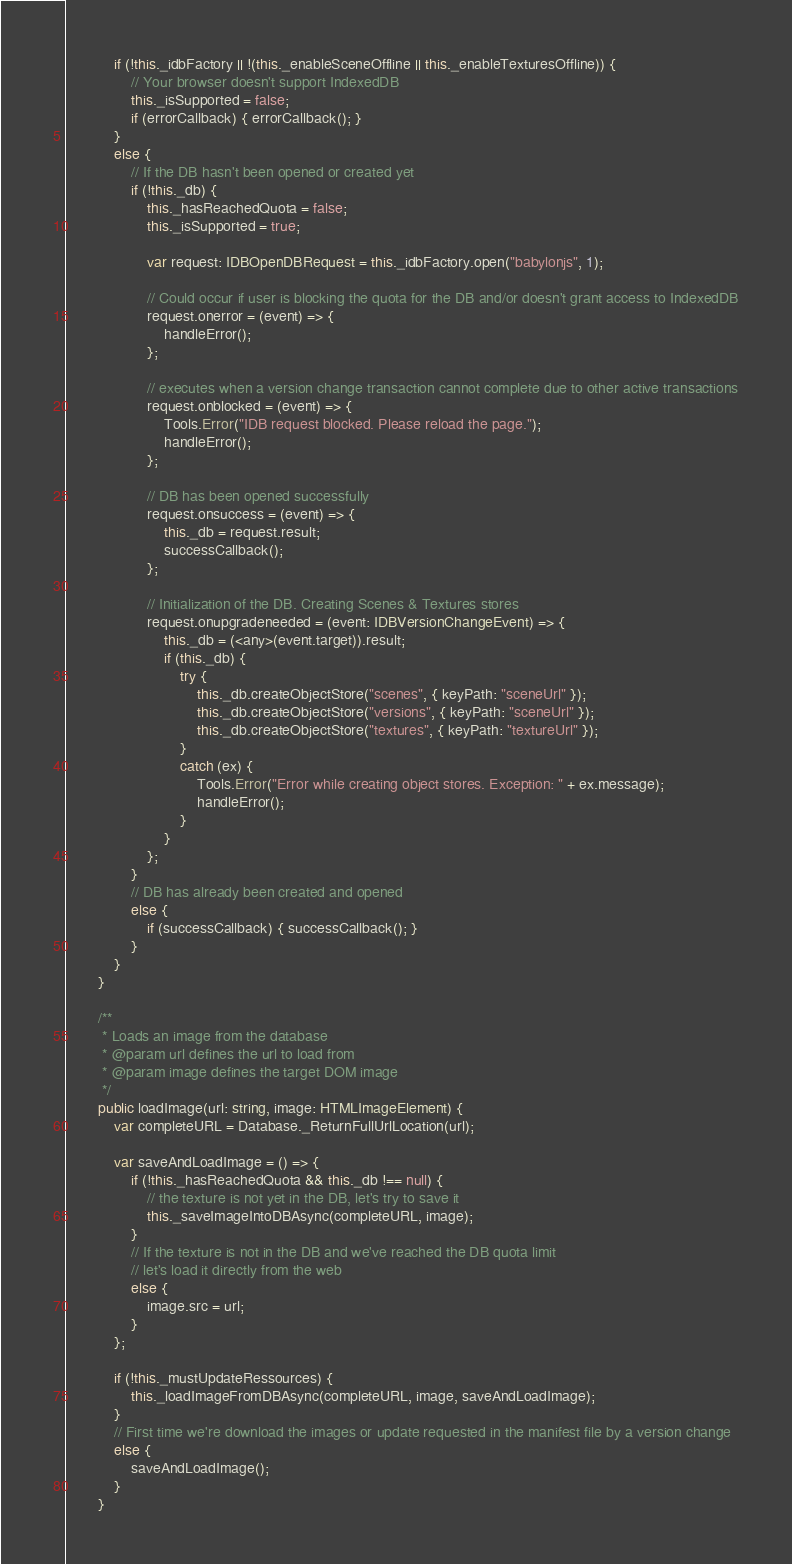<code> <loc_0><loc_0><loc_500><loc_500><_TypeScript_>
            if (!this._idbFactory || !(this._enableSceneOffline || this._enableTexturesOffline)) {
                // Your browser doesn't support IndexedDB
                this._isSupported = false;
                if (errorCallback) { errorCallback(); }
            }
            else {
                // If the DB hasn't been opened or created yet
                if (!this._db) {
                    this._hasReachedQuota = false;
                    this._isSupported = true;

                    var request: IDBOpenDBRequest = this._idbFactory.open("babylonjs", 1);

                    // Could occur if user is blocking the quota for the DB and/or doesn't grant access to IndexedDB
                    request.onerror = (event) => {
                        handleError();
                    };

                    // executes when a version change transaction cannot complete due to other active transactions
                    request.onblocked = (event) => {
                        Tools.Error("IDB request blocked. Please reload the page.");
                        handleError();
                    };

                    // DB has been opened successfully
                    request.onsuccess = (event) => {
                        this._db = request.result;
                        successCallback();
                    };

                    // Initialization of the DB. Creating Scenes & Textures stores
                    request.onupgradeneeded = (event: IDBVersionChangeEvent) => {
                        this._db = (<any>(event.target)).result;
                        if (this._db) {
                            try {
                                this._db.createObjectStore("scenes", { keyPath: "sceneUrl" });
                                this._db.createObjectStore("versions", { keyPath: "sceneUrl" });
                                this._db.createObjectStore("textures", { keyPath: "textureUrl" });
                            }
                            catch (ex) {
                                Tools.Error("Error while creating object stores. Exception: " + ex.message);
                                handleError();
                            }
                        }
                    };
                }
                // DB has already been created and opened
                else {
                    if (successCallback) { successCallback(); }
                }
            }
        }

        /**
         * Loads an image from the database
         * @param url defines the url to load from
         * @param image defines the target DOM image
         */
        public loadImage(url: string, image: HTMLImageElement) {
            var completeURL = Database._ReturnFullUrlLocation(url);

            var saveAndLoadImage = () => {
                if (!this._hasReachedQuota && this._db !== null) {
                    // the texture is not yet in the DB, let's try to save it
                    this._saveImageIntoDBAsync(completeURL, image);
                }
                // If the texture is not in the DB and we've reached the DB quota limit
                // let's load it directly from the web
                else {
                    image.src = url;
                }
            };

            if (!this._mustUpdateRessources) {
                this._loadImageFromDBAsync(completeURL, image, saveAndLoadImage);
            }
            // First time we're download the images or update requested in the manifest file by a version change
            else {
                saveAndLoadImage();
            }
        }
</code> 